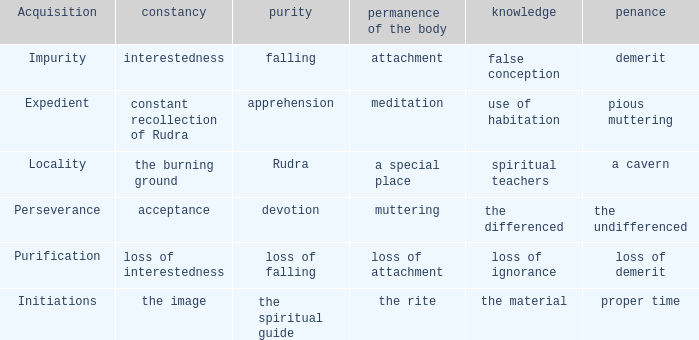 what's the permanence of the body where penance is the undifferenced Muttering. 